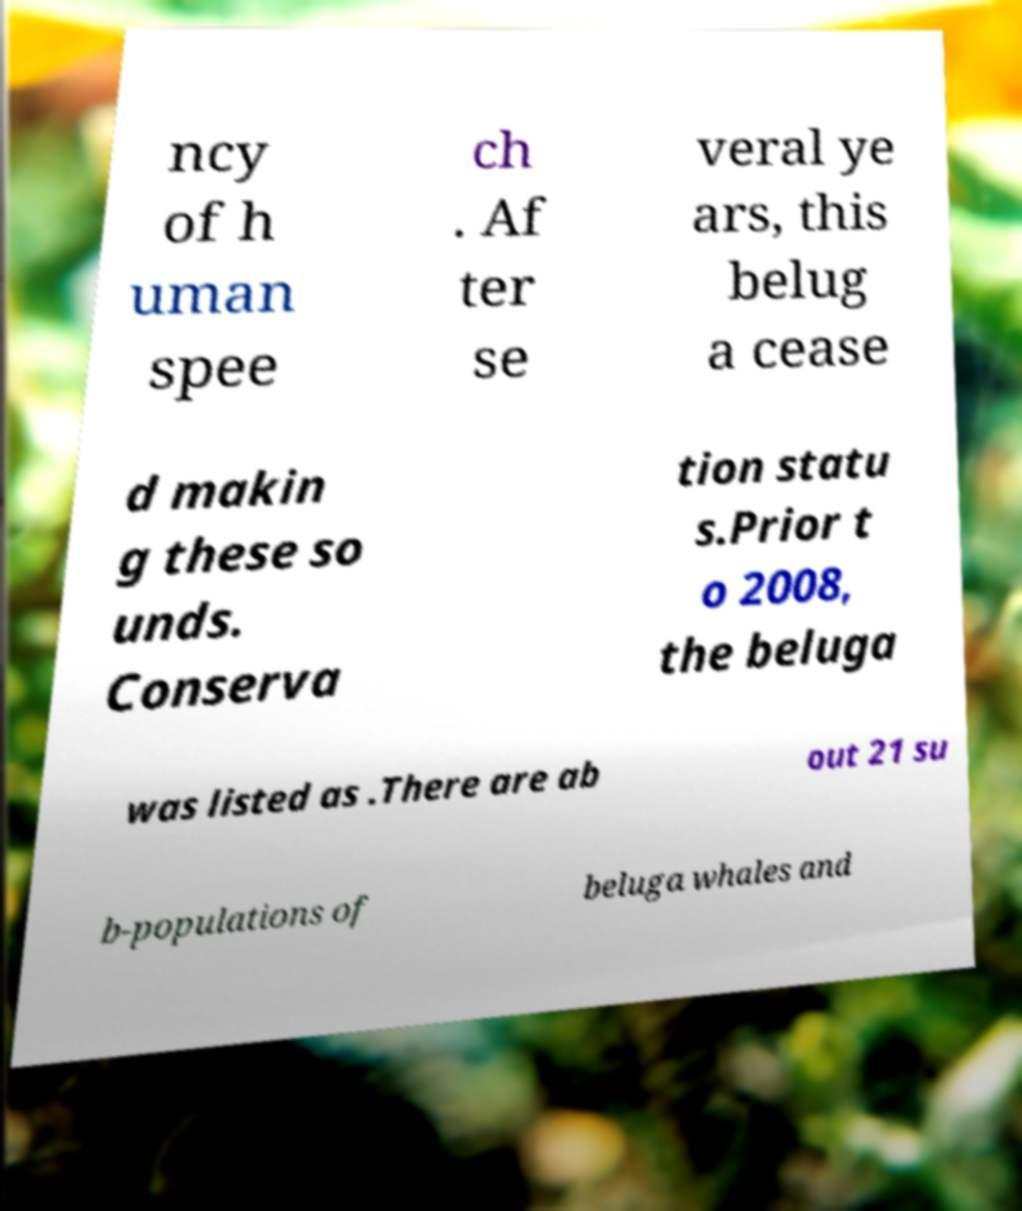Can you accurately transcribe the text from the provided image for me? ncy of h uman spee ch . Af ter se veral ye ars, this belug a cease d makin g these so unds. Conserva tion statu s.Prior t o 2008, the beluga was listed as .There are ab out 21 su b-populations of beluga whales and 